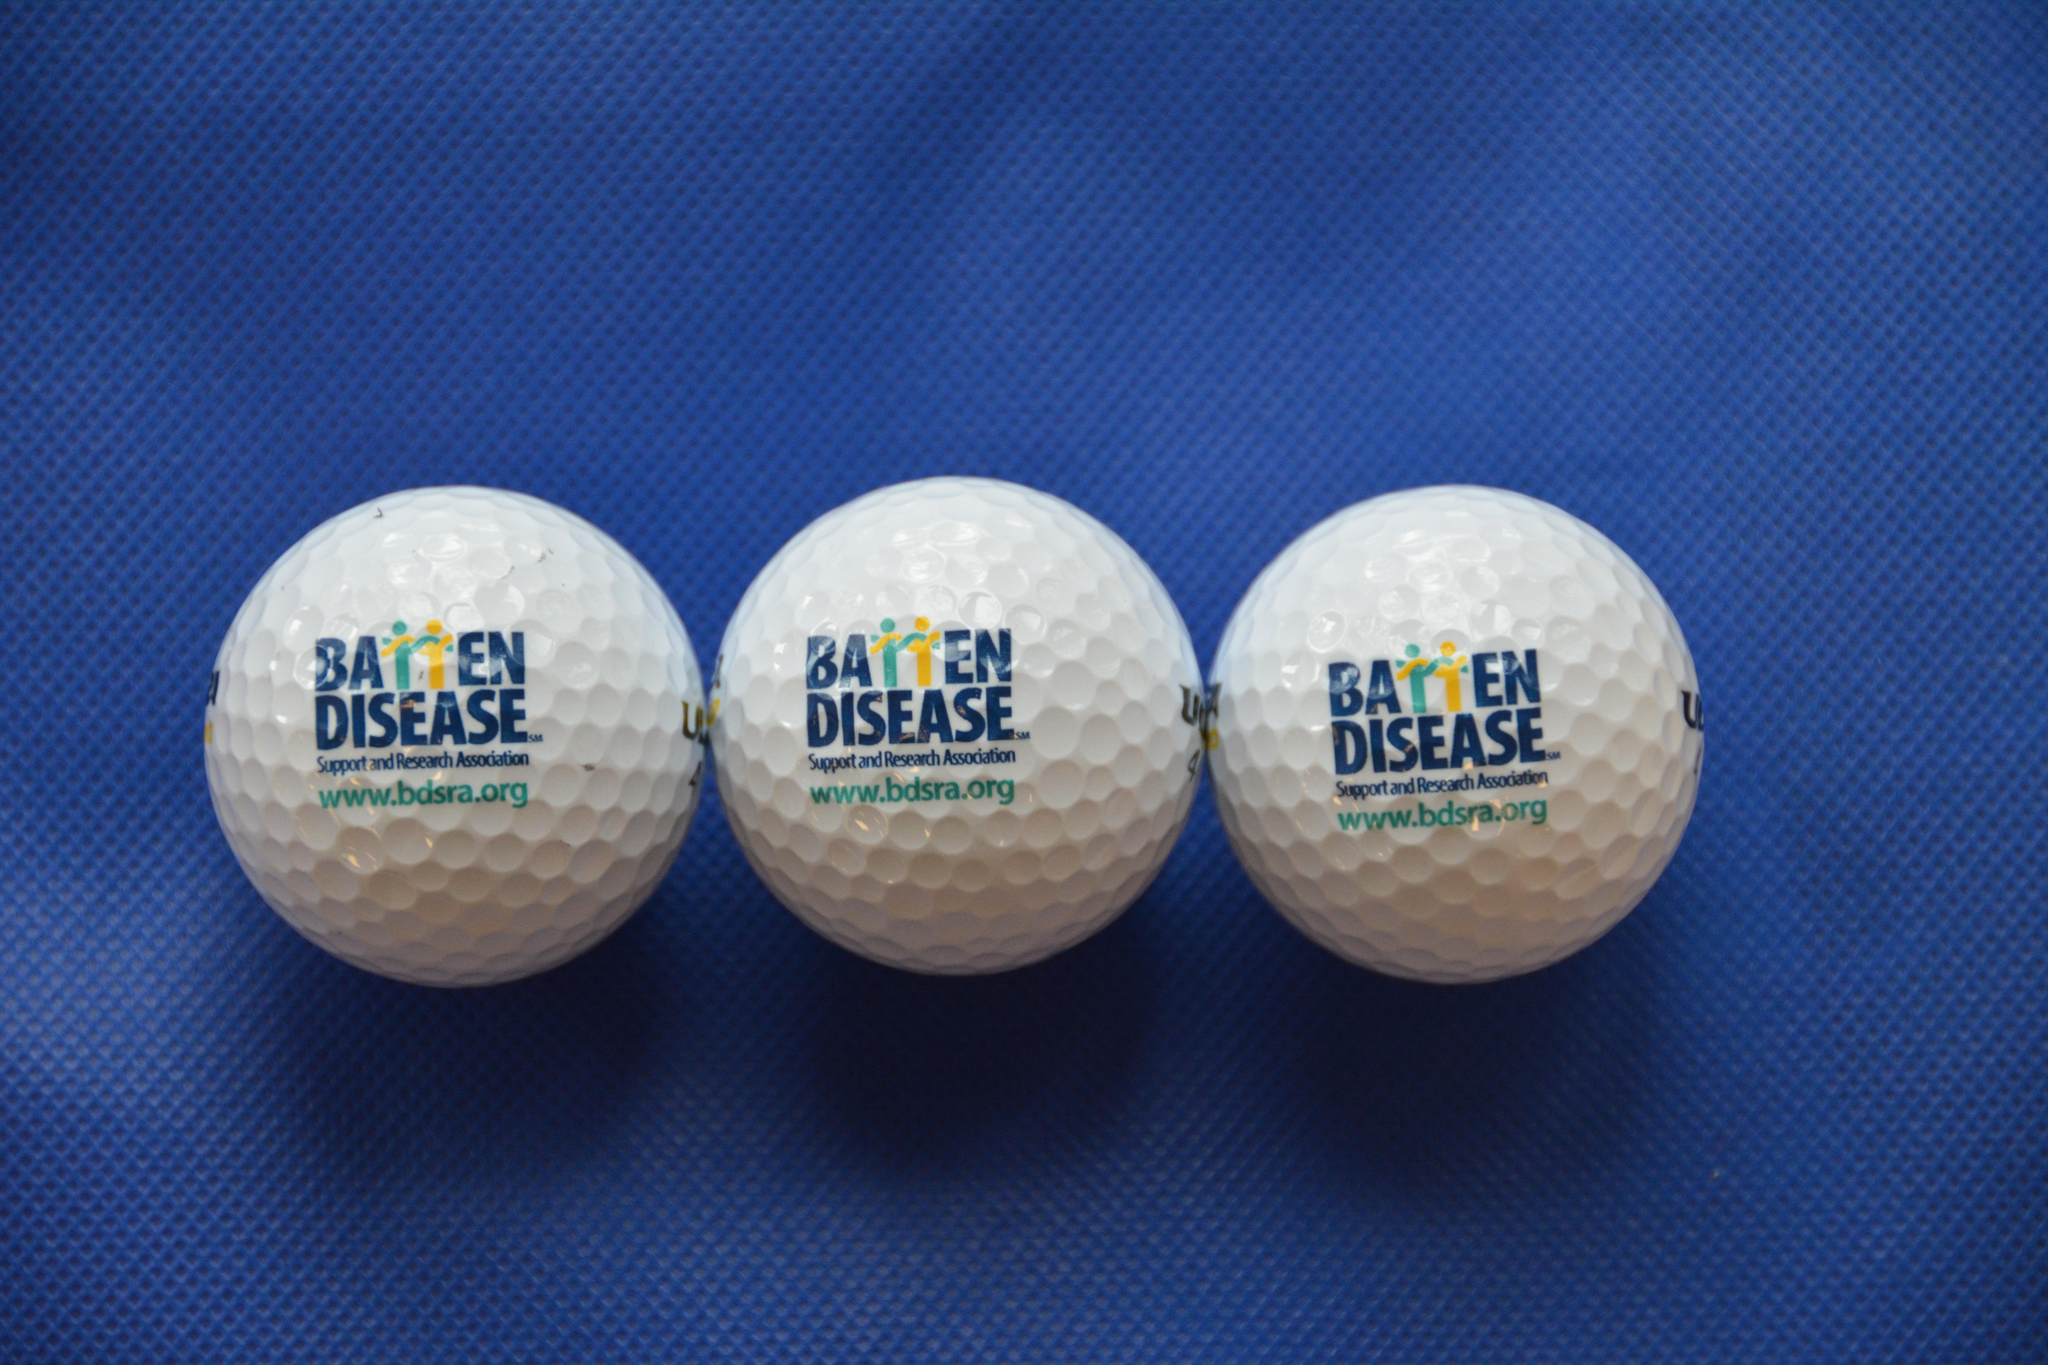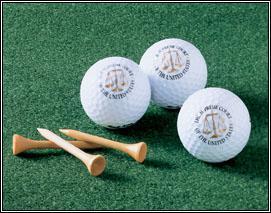The first image is the image on the left, the second image is the image on the right. Given the left and right images, does the statement "There are six white golf balls and at least some of them have T holders under or near them." hold true? Answer yes or no. Yes. The first image is the image on the left, the second image is the image on the right. Examine the images to the left and right. Is the description "there are golf balls in sets of 3" accurate? Answer yes or no. Yes. 